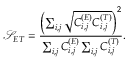Convert formula to latex. <formula><loc_0><loc_0><loc_500><loc_500>\mathcal { S } _ { E T } = \frac { \left ( \sum _ { i , j } \sqrt { C _ { i , j } ^ { ( E ) } C _ { i , j } ^ { ( T ) } } \right ) ^ { 2 } } { \sum _ { i , j } C _ { i , j } ^ { ( E ) } \sum _ { i , j } C _ { i , j } ^ { ( T ) } } .</formula> 